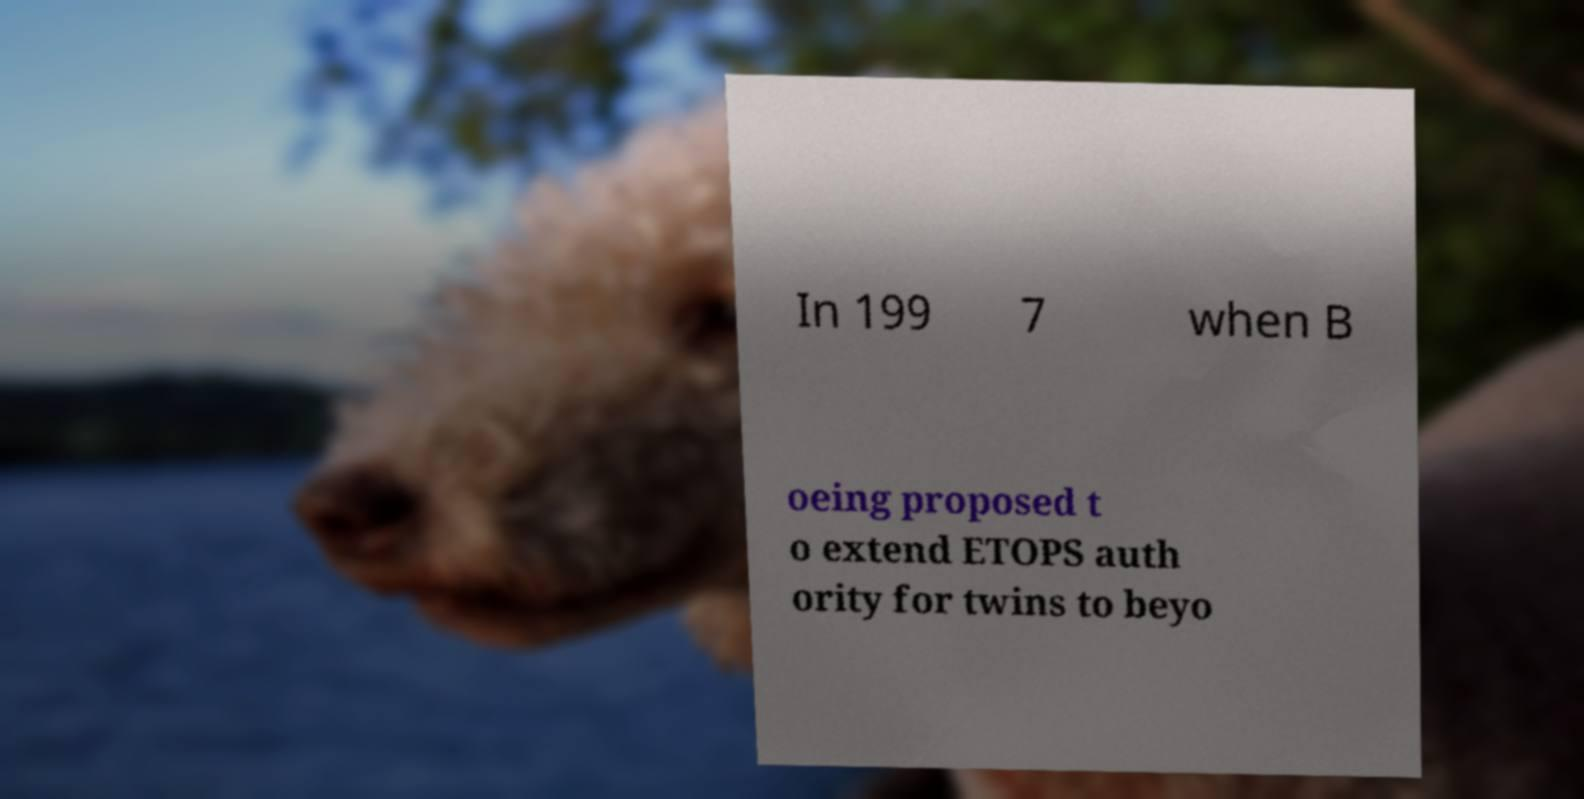Please read and relay the text visible in this image. What does it say? In 199 7 when B oeing proposed t o extend ETOPS auth ority for twins to beyo 